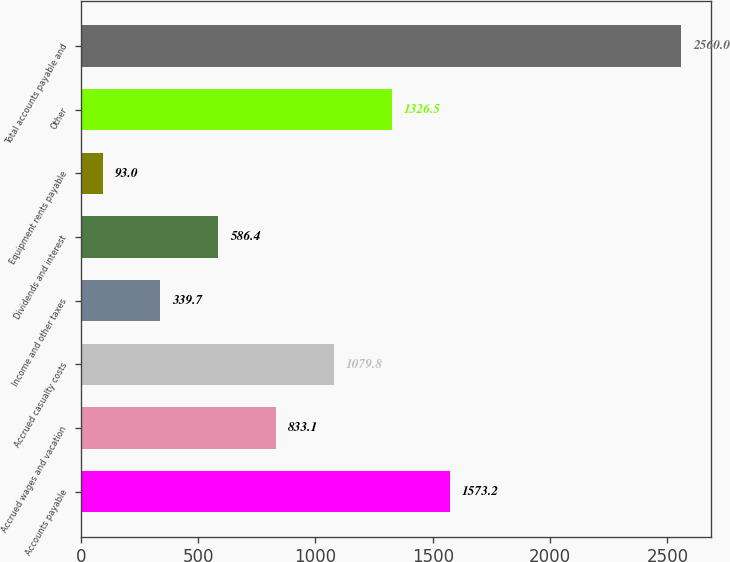Convert chart. <chart><loc_0><loc_0><loc_500><loc_500><bar_chart><fcel>Accounts payable<fcel>Accrued wages and vacation<fcel>Accrued casualty costs<fcel>Income and other taxes<fcel>Dividends and interest<fcel>Equipment rents payable<fcel>Other<fcel>Total accounts payable and<nl><fcel>1573.2<fcel>833.1<fcel>1079.8<fcel>339.7<fcel>586.4<fcel>93<fcel>1326.5<fcel>2560<nl></chart> 